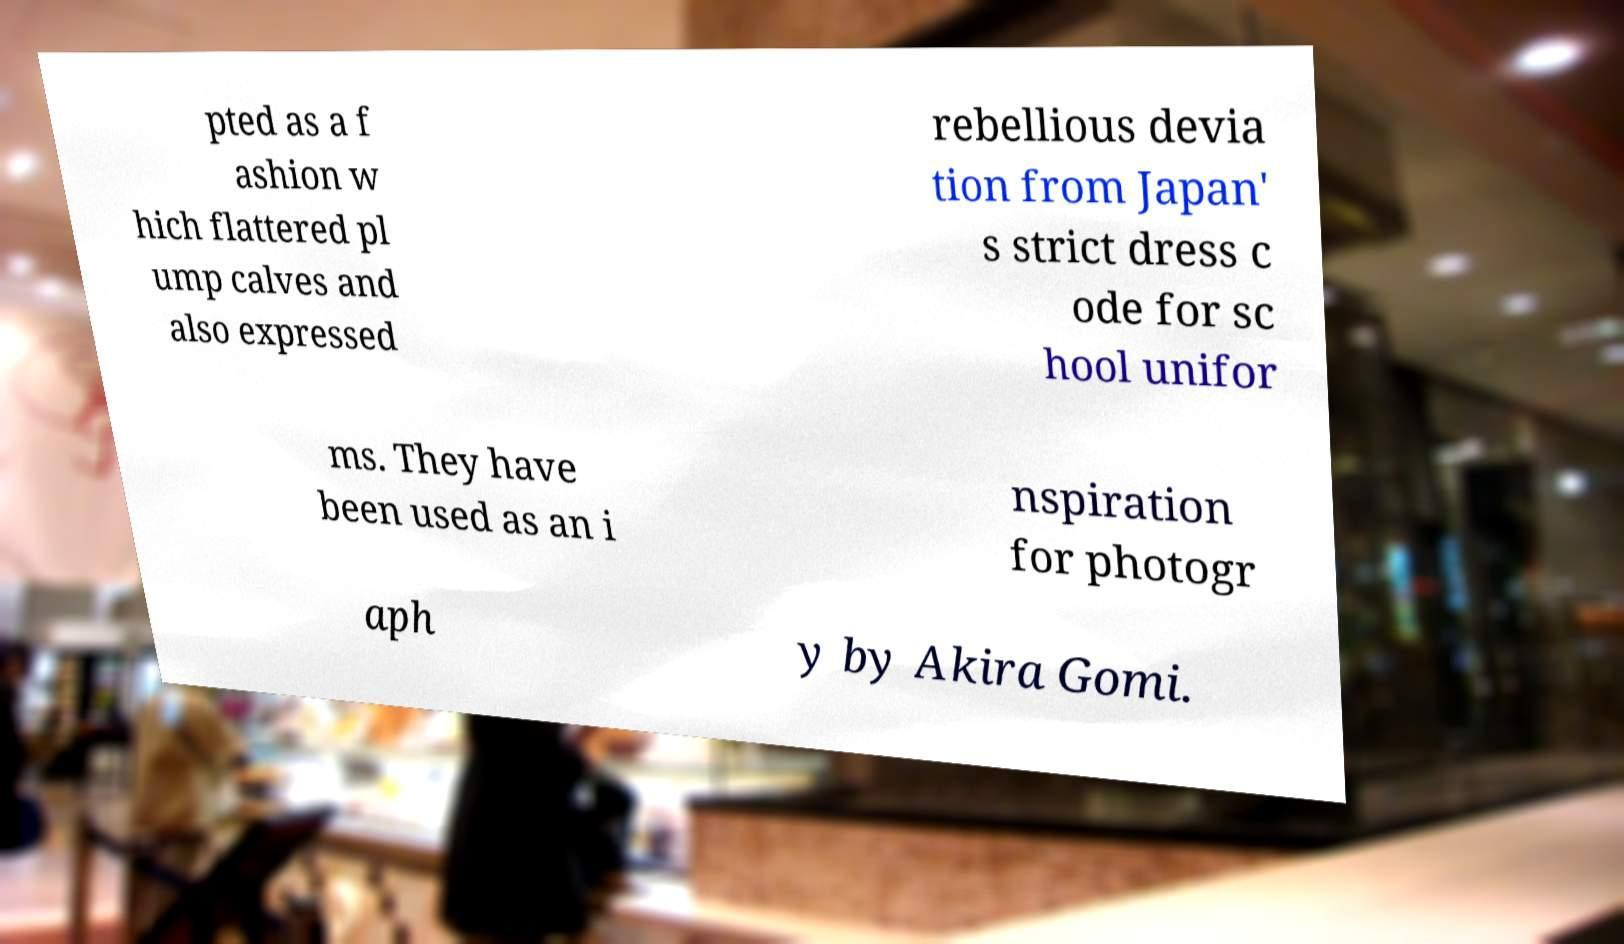Please read and relay the text visible in this image. What does it say? pted as a f ashion w hich flattered pl ump calves and also expressed rebellious devia tion from Japan' s strict dress c ode for sc hool unifor ms. They have been used as an i nspiration for photogr aph y by Akira Gomi. 